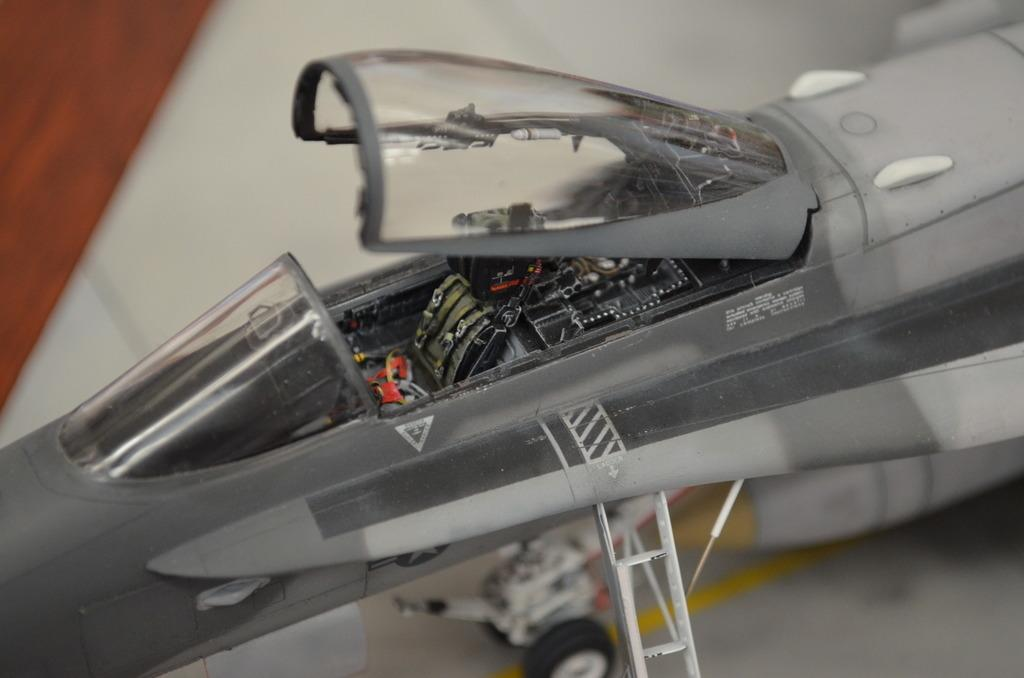What is the main subject of the picture? The main subject of the picture is an aircraft. Can you describe the background of the image? The background of the image is blurred. What type of wire is being used to make decisions in the image? There is no wire or decision-making process depicted in the image; it features an aircraft with a blurred background. Can you see any pigs in the image? There are no pigs present in the image. 